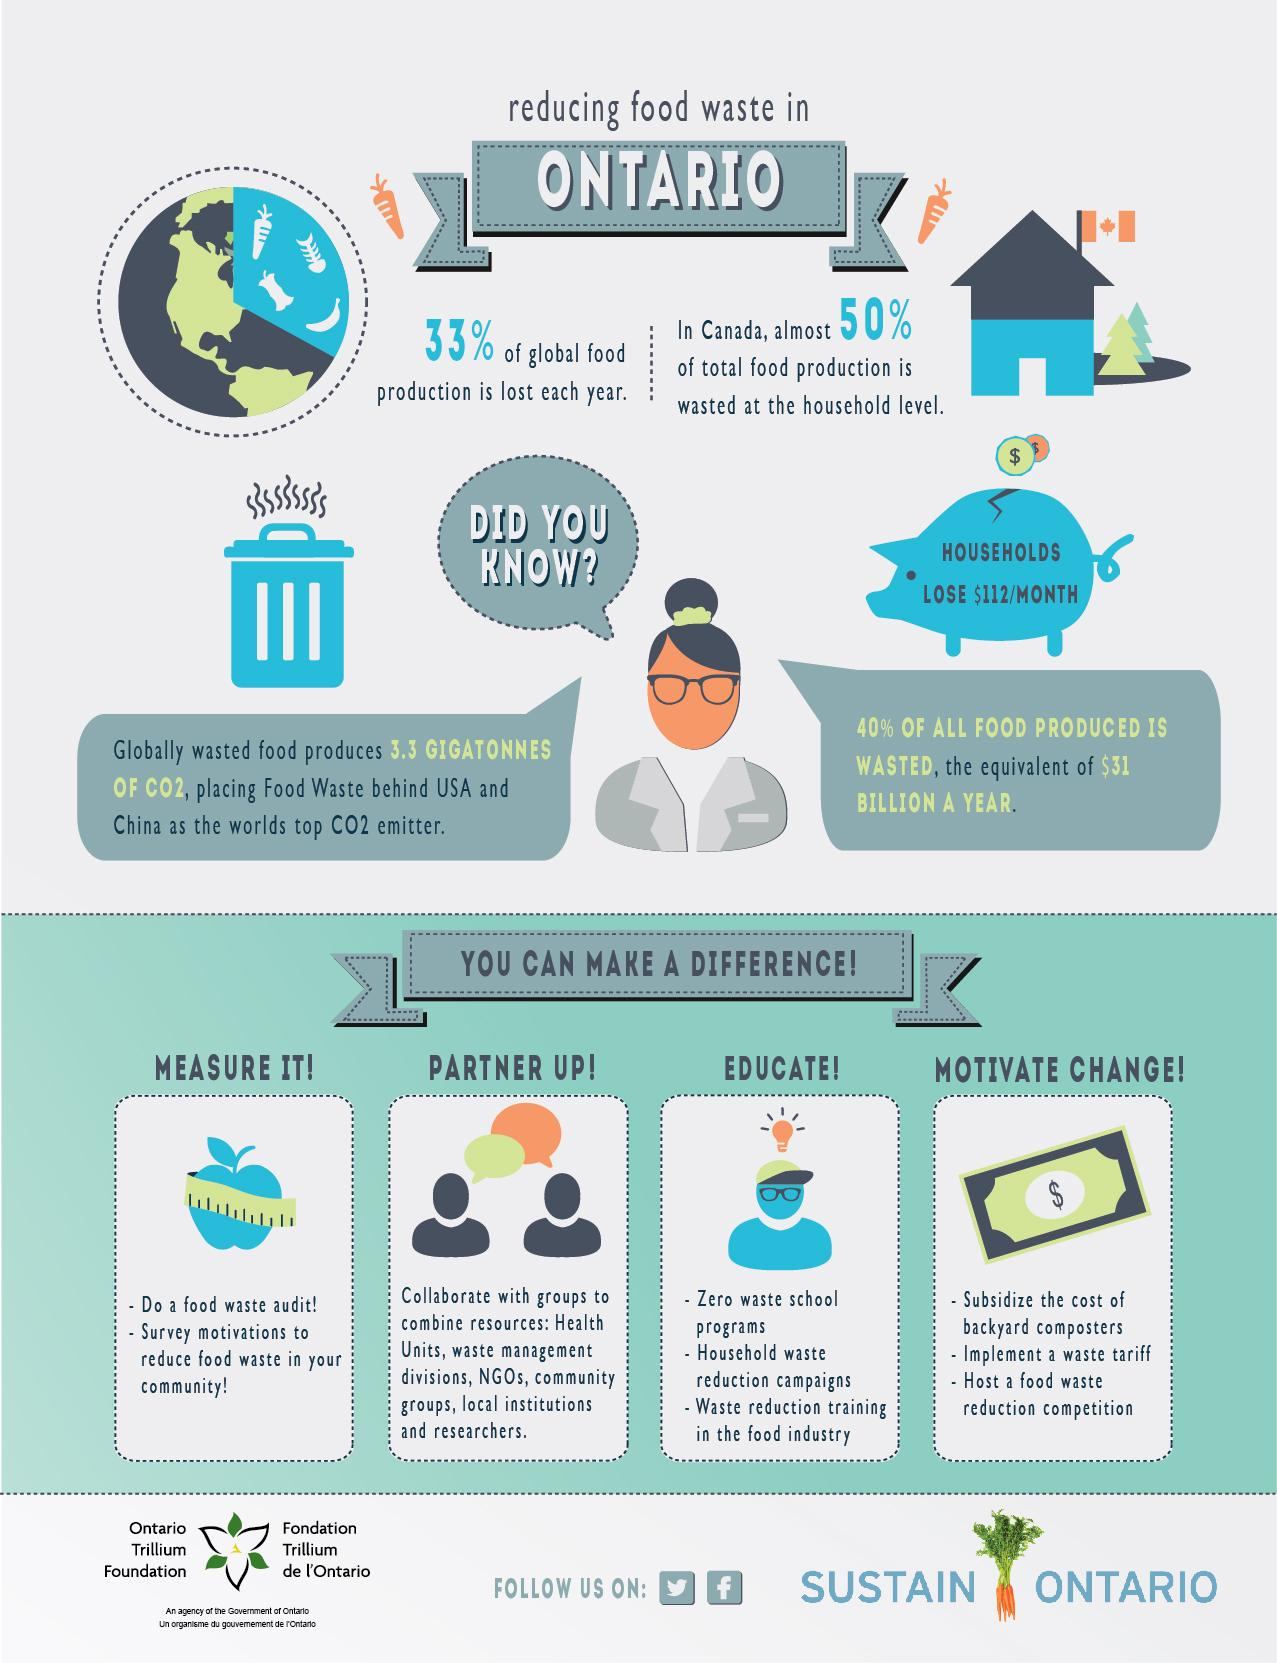Draw attention to some important aspects in this diagram. According to recent estimates, approximately 77% of global food production is not wasted each year. The image of a dollar note represents the fourth way to make a difference, which is motivating change. The mention of multiple ways to make a difference in this text is impressive, with a total of four ways being mentioned. We propose hosting a food waste reduction competition to motivate change and inspire action towards a more sustainable future. This competition will provide a platform for individuals, organizations, and communities to showcase their innovative ideas and initiatives towards reducing food waste. By highlighting best practices and successful case studies, we aim to create a positive impact and promote a culture of sustainability and conservation. The two countries that emit the most carbon dioxide in the world are the United States and China. 